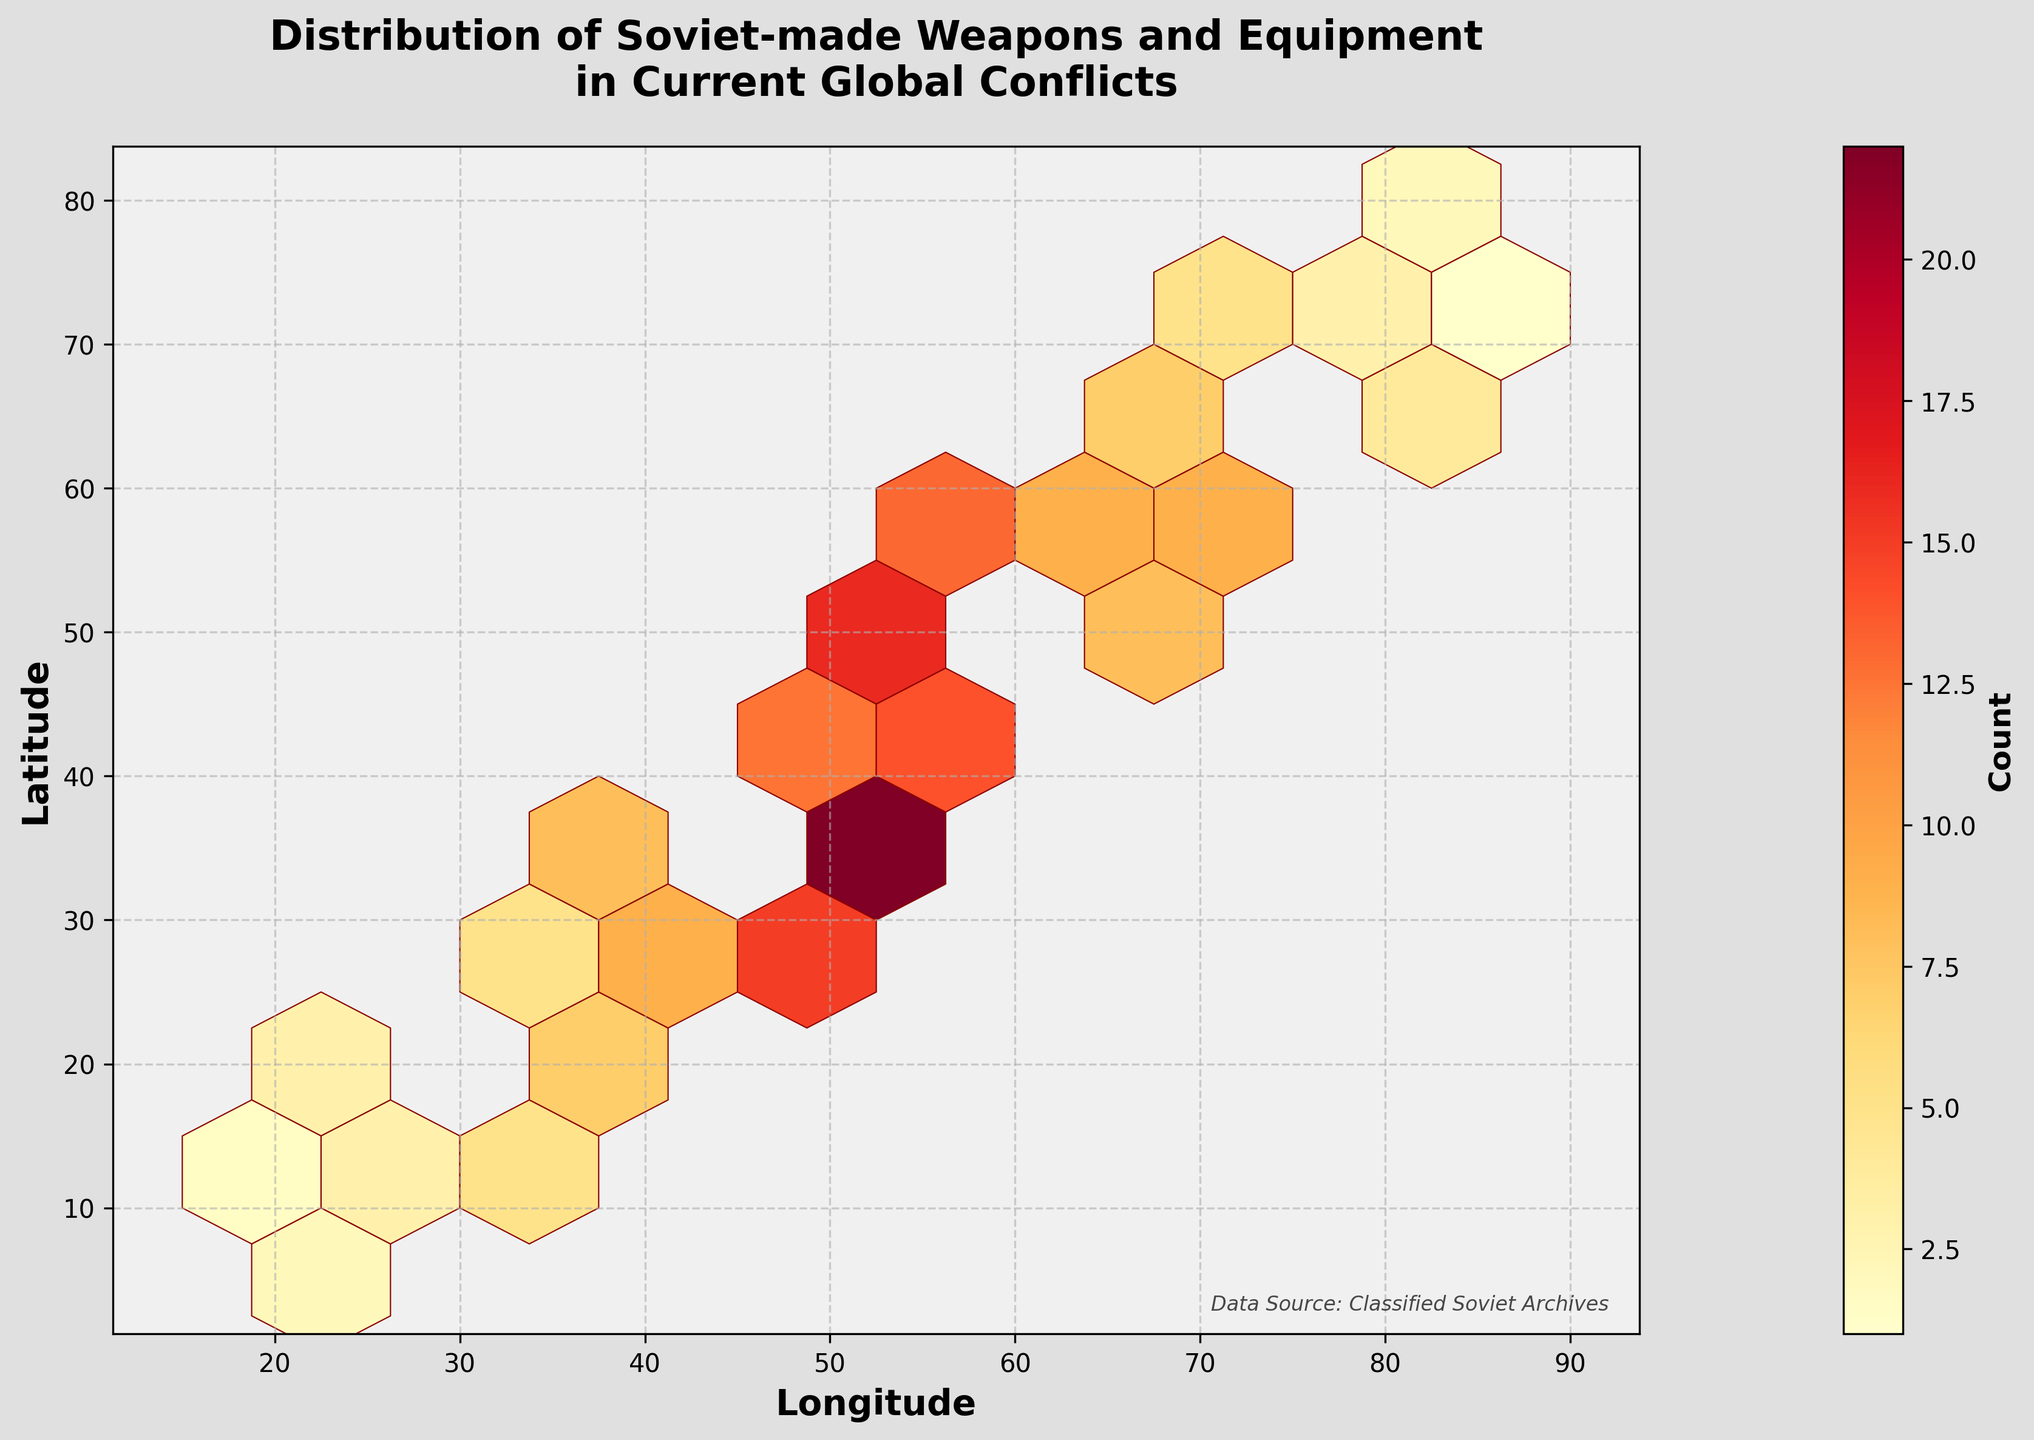How many total hexagon bins are present in the plot? Count the hexagon bins visible in the plot.
Answer: 30 What is the title of the figure? Look at the top of the figure to identify the title.
Answer: Distribution of Soviet-made Weapons and Equipment in Current Global Conflicts What color represents the highest count in the hexagon bins? Observe the color mapping and identify the darkest or most intense color associated with the highest count.
Answer: Dark Red How many hexagon bins represent a count of 1? Count the hexagon bins with the lightest color on the plot, which corresponds to the lower end of the color bar.
Answer: 3 What are the longitude and latitude values for the hexagon bin with the highest count? Identify the hexagon bin with the darkest color and refer to its position on the axis.
Answer: (50, 35) Which region, represented by longitude and latitude, shows a concentration of counts between 10 and 16? Look for hexagon bins that match the color values corresponding to counts between 10 and 16 in the color map and refer to their positions.
Answer: Around (55, 50) to (60, 55) If you sum the counts of hexagon bins corresponding to latitude between 40 and 55, what is the total? Identify bins with latitude between 40 and 55, add the associated counts to find the total.
Answer: 45 Compare the count at (45, 30) with the count at (50, 35). Which location has a higher count and by how much? Identify the count values at these coordinates and find the difference.
Answer: (50, 35) is higher by 7 What can you infer about the distribution of Soviet-made weapons in global conflicts based on the hexbin plot? Analyze the overall pattern of hexagon bins, color intensities, and geographic spread to draw conclusions.
Answer: Concentrated in limited regions with several moderately-high counts How does the count in hexagon bins shift as you move from longitude 20 to 85? Observe the color intensity changes relative to the longitude axis to identify counts' trends from left to right.
Answer: Decreases and then sporadically increases 